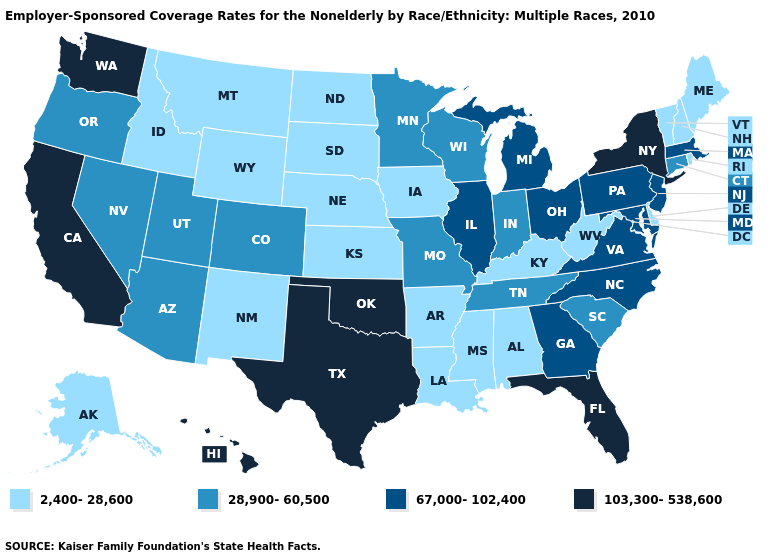Is the legend a continuous bar?
Answer briefly. No. Name the states that have a value in the range 67,000-102,400?
Be succinct. Georgia, Illinois, Maryland, Massachusetts, Michigan, New Jersey, North Carolina, Ohio, Pennsylvania, Virginia. What is the lowest value in states that border Indiana?
Answer briefly. 2,400-28,600. Does Missouri have the same value as Indiana?
Write a very short answer. Yes. Name the states that have a value in the range 103,300-538,600?
Short answer required. California, Florida, Hawaii, New York, Oklahoma, Texas, Washington. What is the value of New York?
Concise answer only. 103,300-538,600. What is the lowest value in the MidWest?
Answer briefly. 2,400-28,600. Name the states that have a value in the range 67,000-102,400?
Be succinct. Georgia, Illinois, Maryland, Massachusetts, Michigan, New Jersey, North Carolina, Ohio, Pennsylvania, Virginia. Which states have the lowest value in the South?
Keep it brief. Alabama, Arkansas, Delaware, Kentucky, Louisiana, Mississippi, West Virginia. Which states have the lowest value in the West?
Give a very brief answer. Alaska, Idaho, Montana, New Mexico, Wyoming. What is the value of North Dakota?
Be succinct. 2,400-28,600. Name the states that have a value in the range 28,900-60,500?
Give a very brief answer. Arizona, Colorado, Connecticut, Indiana, Minnesota, Missouri, Nevada, Oregon, South Carolina, Tennessee, Utah, Wisconsin. Name the states that have a value in the range 103,300-538,600?
Quick response, please. California, Florida, Hawaii, New York, Oklahoma, Texas, Washington. Among the states that border Washington , does Oregon have the highest value?
Answer briefly. Yes. 